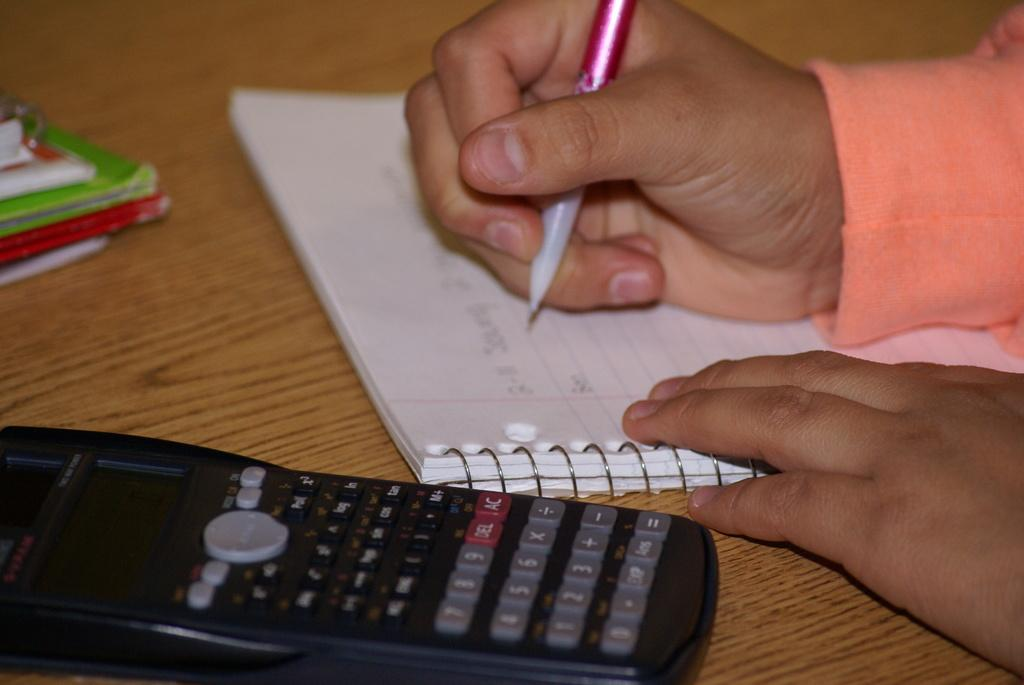<image>
Relay a brief, clear account of the picture shown. The first number in a math problem on a piece of lined paper is two. 